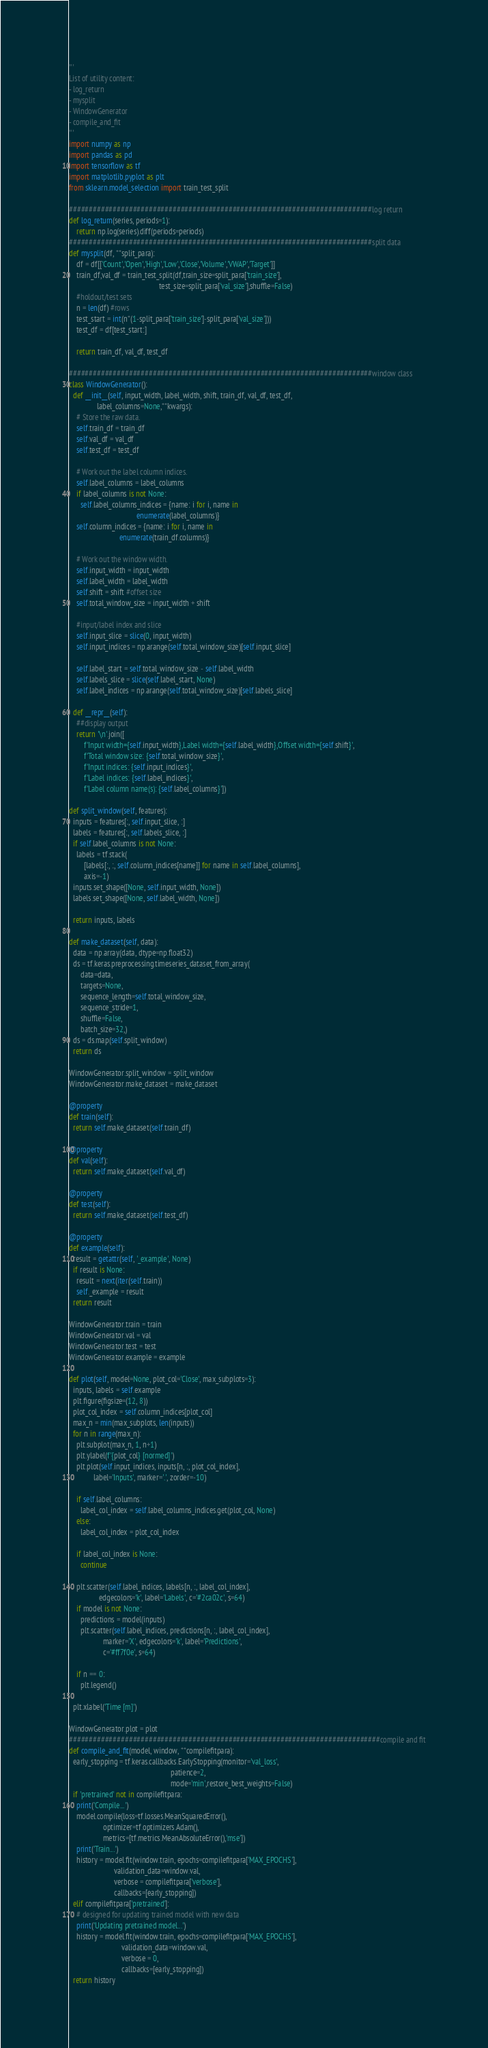Convert code to text. <code><loc_0><loc_0><loc_500><loc_500><_Python_>'''
List of utility content:
- log_return
- mysplit
- WindowGenerator
- compile_and_fit
'''
import numpy as np
import pandas as pd
import tensorflow as tf
import matplotlib.pyplot as plt
from sklearn.model_selection import train_test_split

############################################################################log return
def log_return(series, periods=1):
    return np.log(series).diff(periods=periods)
############################################################################split data
def mysplit(df, **split_para):
    df = df[['Count','Open','High','Low','Close','Volume','VWAP','Target']]
    train_df,val_df = train_test_split(df,train_size=split_para['train_size'],
                                                test_size=split_para['val_size'],shuffle=False)
    #holdout/test sets
    n = len(df) #rows
    test_start = int(n*(1-split_para['train_size']-split_para['val_size']))
    test_df = df[test_start:]

    return train_df, val_df, test_df

############################################################################window class
class WindowGenerator():
  def __init__(self, input_width, label_width, shift, train_df, val_df, test_df,
               label_columns=None,**kwargs):
    # Store the raw data.
    self.train_df = train_df
    self.val_df = val_df
    self.test_df = test_df

    # Work out the label column indices.
    self.label_columns = label_columns
    if label_columns is not None:
      self.label_columns_indices = {name: i for i, name in
                                    enumerate(label_columns)}
    self.column_indices = {name: i for i, name in
                           enumerate(train_df.columns)}

    # Work out the window width.
    self.input_width = input_width
    self.label_width = label_width
    self.shift = shift #offset size
    self.total_window_size = input_width + shift

    #input/label index and slice
    self.input_slice = slice(0, input_width)
    self.input_indices = np.arange(self.total_window_size)[self.input_slice]

    self.label_start = self.total_window_size - self.label_width
    self.labels_slice = slice(self.label_start, None)
    self.label_indices = np.arange(self.total_window_size)[self.labels_slice]

  def __repr__(self):
    ##display output
    return '\n'.join([
        f'Input width={self.input_width},Label width={self.label_width},Offset width={self.shift}',
        f'Total window size: {self.total_window_size}',
        f'Input indices: {self.input_indices}',
        f'Label indices: {self.label_indices}',
        f'Label column name(s): {self.label_columns}'])

def split_window(self, features):
  inputs = features[:, self.input_slice, :]
  labels = features[:, self.labels_slice, :]
  if self.label_columns is not None:
    labels = tf.stack(
        [labels[:, :, self.column_indices[name]] for name in self.label_columns],
        axis=-1)
  inputs.set_shape([None, self.input_width, None])
  labels.set_shape([None, self.label_width, None])

  return inputs, labels

def make_dataset(self, data):
  data = np.array(data, dtype=np.float32)
  ds = tf.keras.preprocessing.timeseries_dataset_from_array(
      data=data,
      targets=None,
      sequence_length=self.total_window_size,
      sequence_stride=1,
      shuffle=False,
      batch_size=32,)
  ds = ds.map(self.split_window)
  return ds

WindowGenerator.split_window = split_window
WindowGenerator.make_dataset = make_dataset

@property
def train(self):
  return self.make_dataset(self.train_df)

@property
def val(self):
  return self.make_dataset(self.val_df)

@property
def test(self):
  return self.make_dataset(self.test_df)

@property
def example(self):
  result = getattr(self, '_example', None)
  if result is None:
    result = next(iter(self.train))
    self._example = result
  return result

WindowGenerator.train = train
WindowGenerator.val = val
WindowGenerator.test = test
WindowGenerator.example = example

def plot(self, model=None, plot_col='Close', max_subplots=3):
  inputs, labels = self.example
  plt.figure(figsize=(12, 8))
  plot_col_index = self.column_indices[plot_col]
  max_n = min(max_subplots, len(inputs))
  for n in range(max_n):
    plt.subplot(max_n, 1, n+1)
    plt.ylabel(f'{plot_col} [normed]')
    plt.plot(self.input_indices, inputs[n, :, plot_col_index],
             label='Inputs', marker='.', zorder=-10)

    if self.label_columns:
      label_col_index = self.label_columns_indices.get(plot_col, None)
    else:
      label_col_index = plot_col_index

    if label_col_index is None:
      continue

    plt.scatter(self.label_indices, labels[n, :, label_col_index],
                edgecolors='k', label='Labels', c='#2ca02c', s=64)
    if model is not None:
      predictions = model(inputs)
      plt.scatter(self.label_indices, predictions[n, :, label_col_index],
                  marker='X', edgecolors='k', label='Predictions',
                  c='#ff7f0e', s=64)

    if n == 0:
      plt.legend()

  plt.xlabel('Time [m]')

WindowGenerator.plot = plot
##############################################################################compile and fit
def compile_and_fit(model, window, **compilefitpara):
  early_stopping = tf.keras.callbacks.EarlyStopping(monitor='val_loss',
                                                      patience=2,
                                                      mode='min',restore_best_weights=False)
  if 'pretrained' not in compilefitpara:
    print('Compile...')
    model.compile(loss=tf.losses.MeanSquaredError(),
                  optimizer=tf.optimizers.Adam(),
                  metrics=[tf.metrics.MeanAbsoluteError(),'mse'])
    print('Train...')
    history = model.fit(window.train, epochs=compilefitpara['MAX_EPOCHS'],
                        validation_data=window.val,
                        verbose = compilefitpara['verbose'],
                        callbacks=[early_stopping])
  elif compilefitpara['pretrained']:
    # designed for updating trained model with new data
    print('Updating pretrained model...')
    history = model.fit(window.train, epochs=compilefitpara['MAX_EPOCHS'],
                            validation_data=window.val,
                            verbose = 0,
                            callbacks=[early_stopping])
  return history

</code> 